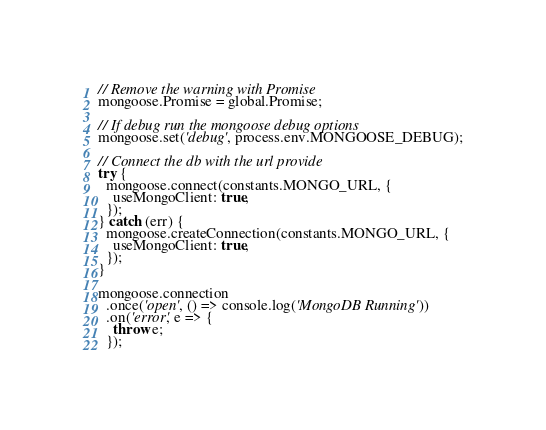<code> <loc_0><loc_0><loc_500><loc_500><_JavaScript_>
// Remove the warning with Promise
mongoose.Promise = global.Promise;

// If debug run the mongoose debug options
mongoose.set('debug', process.env.MONGOOSE_DEBUG);

// Connect the db with the url provide
try {
  mongoose.connect(constants.MONGO_URL, {
    useMongoClient: true,
  });
} catch (err) {
  mongoose.createConnection(constants.MONGO_URL, {
    useMongoClient: true,
  });
}

mongoose.connection
  .once('open', () => console.log('MongoDB Running'))
  .on('error', e => {
    throw e;
  });
</code> 